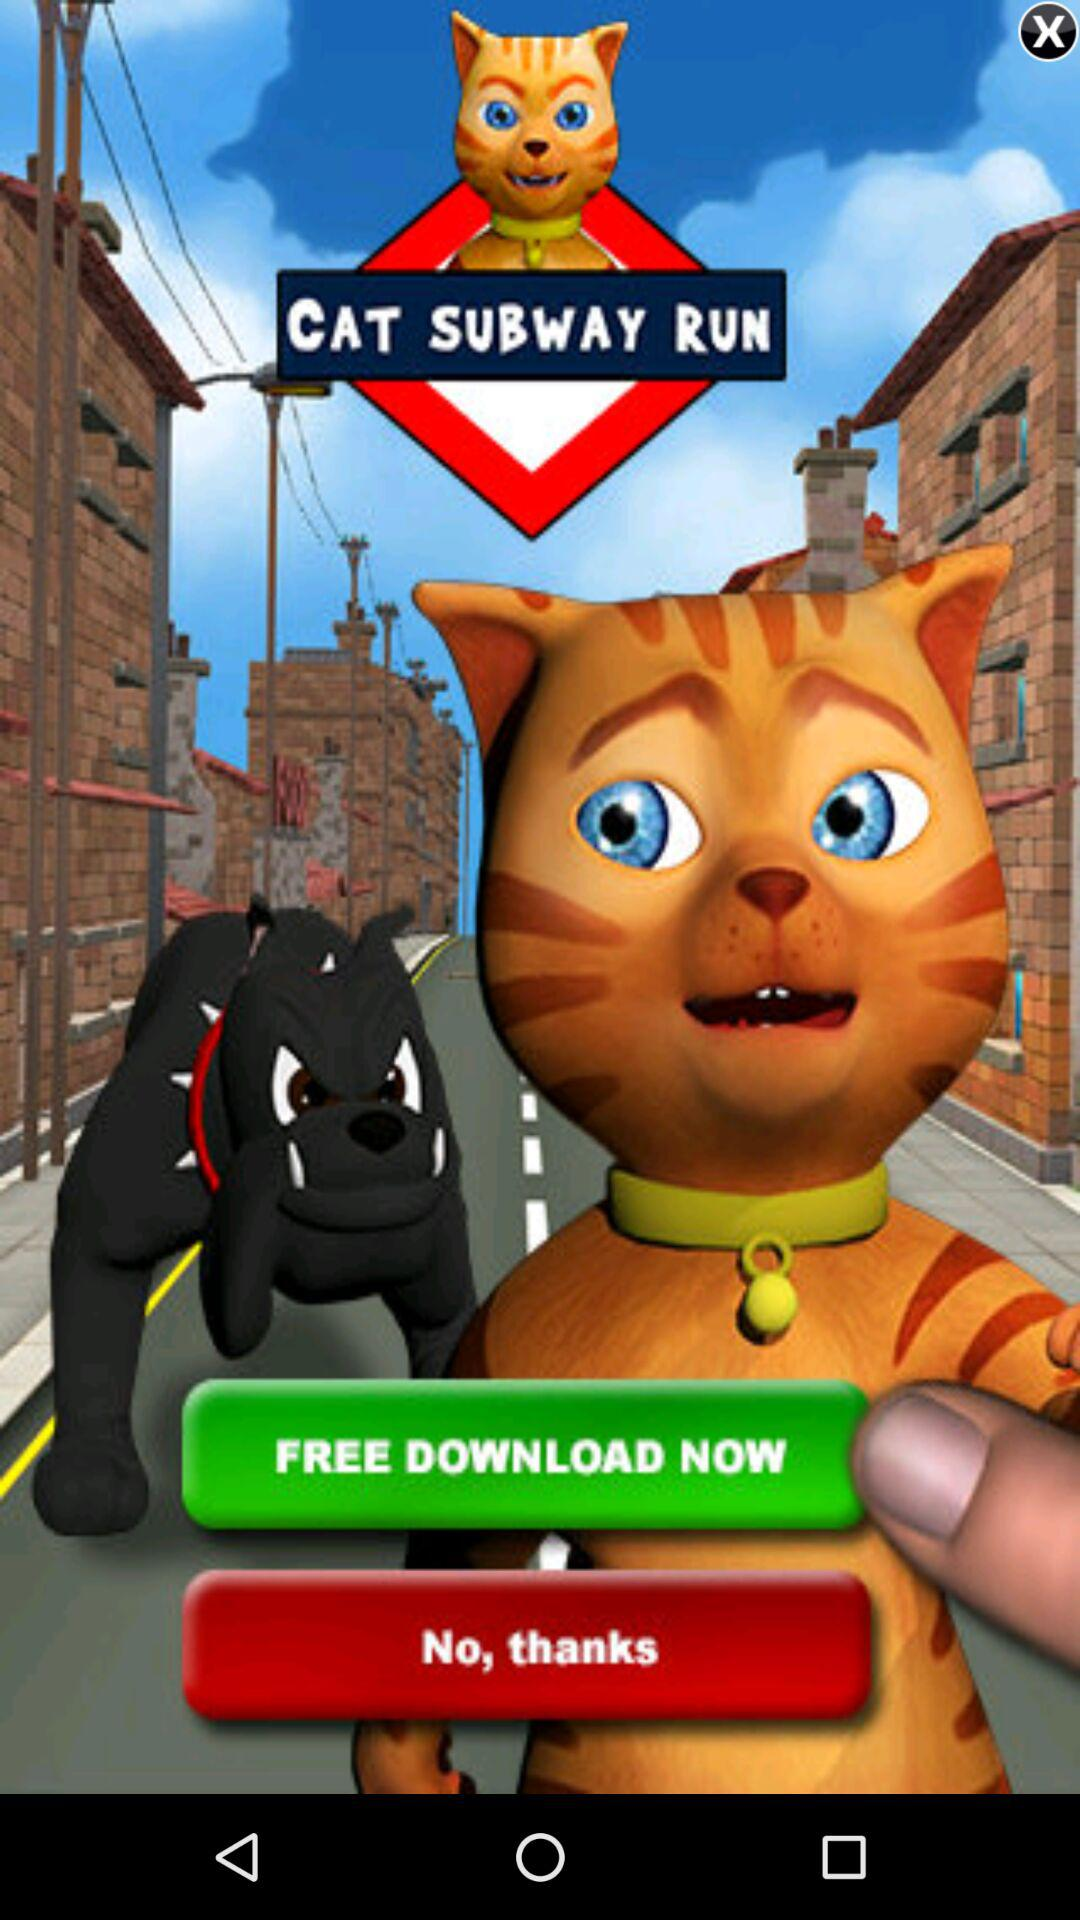What is the application name? The application name is "CAT SUBWAY RUN". 